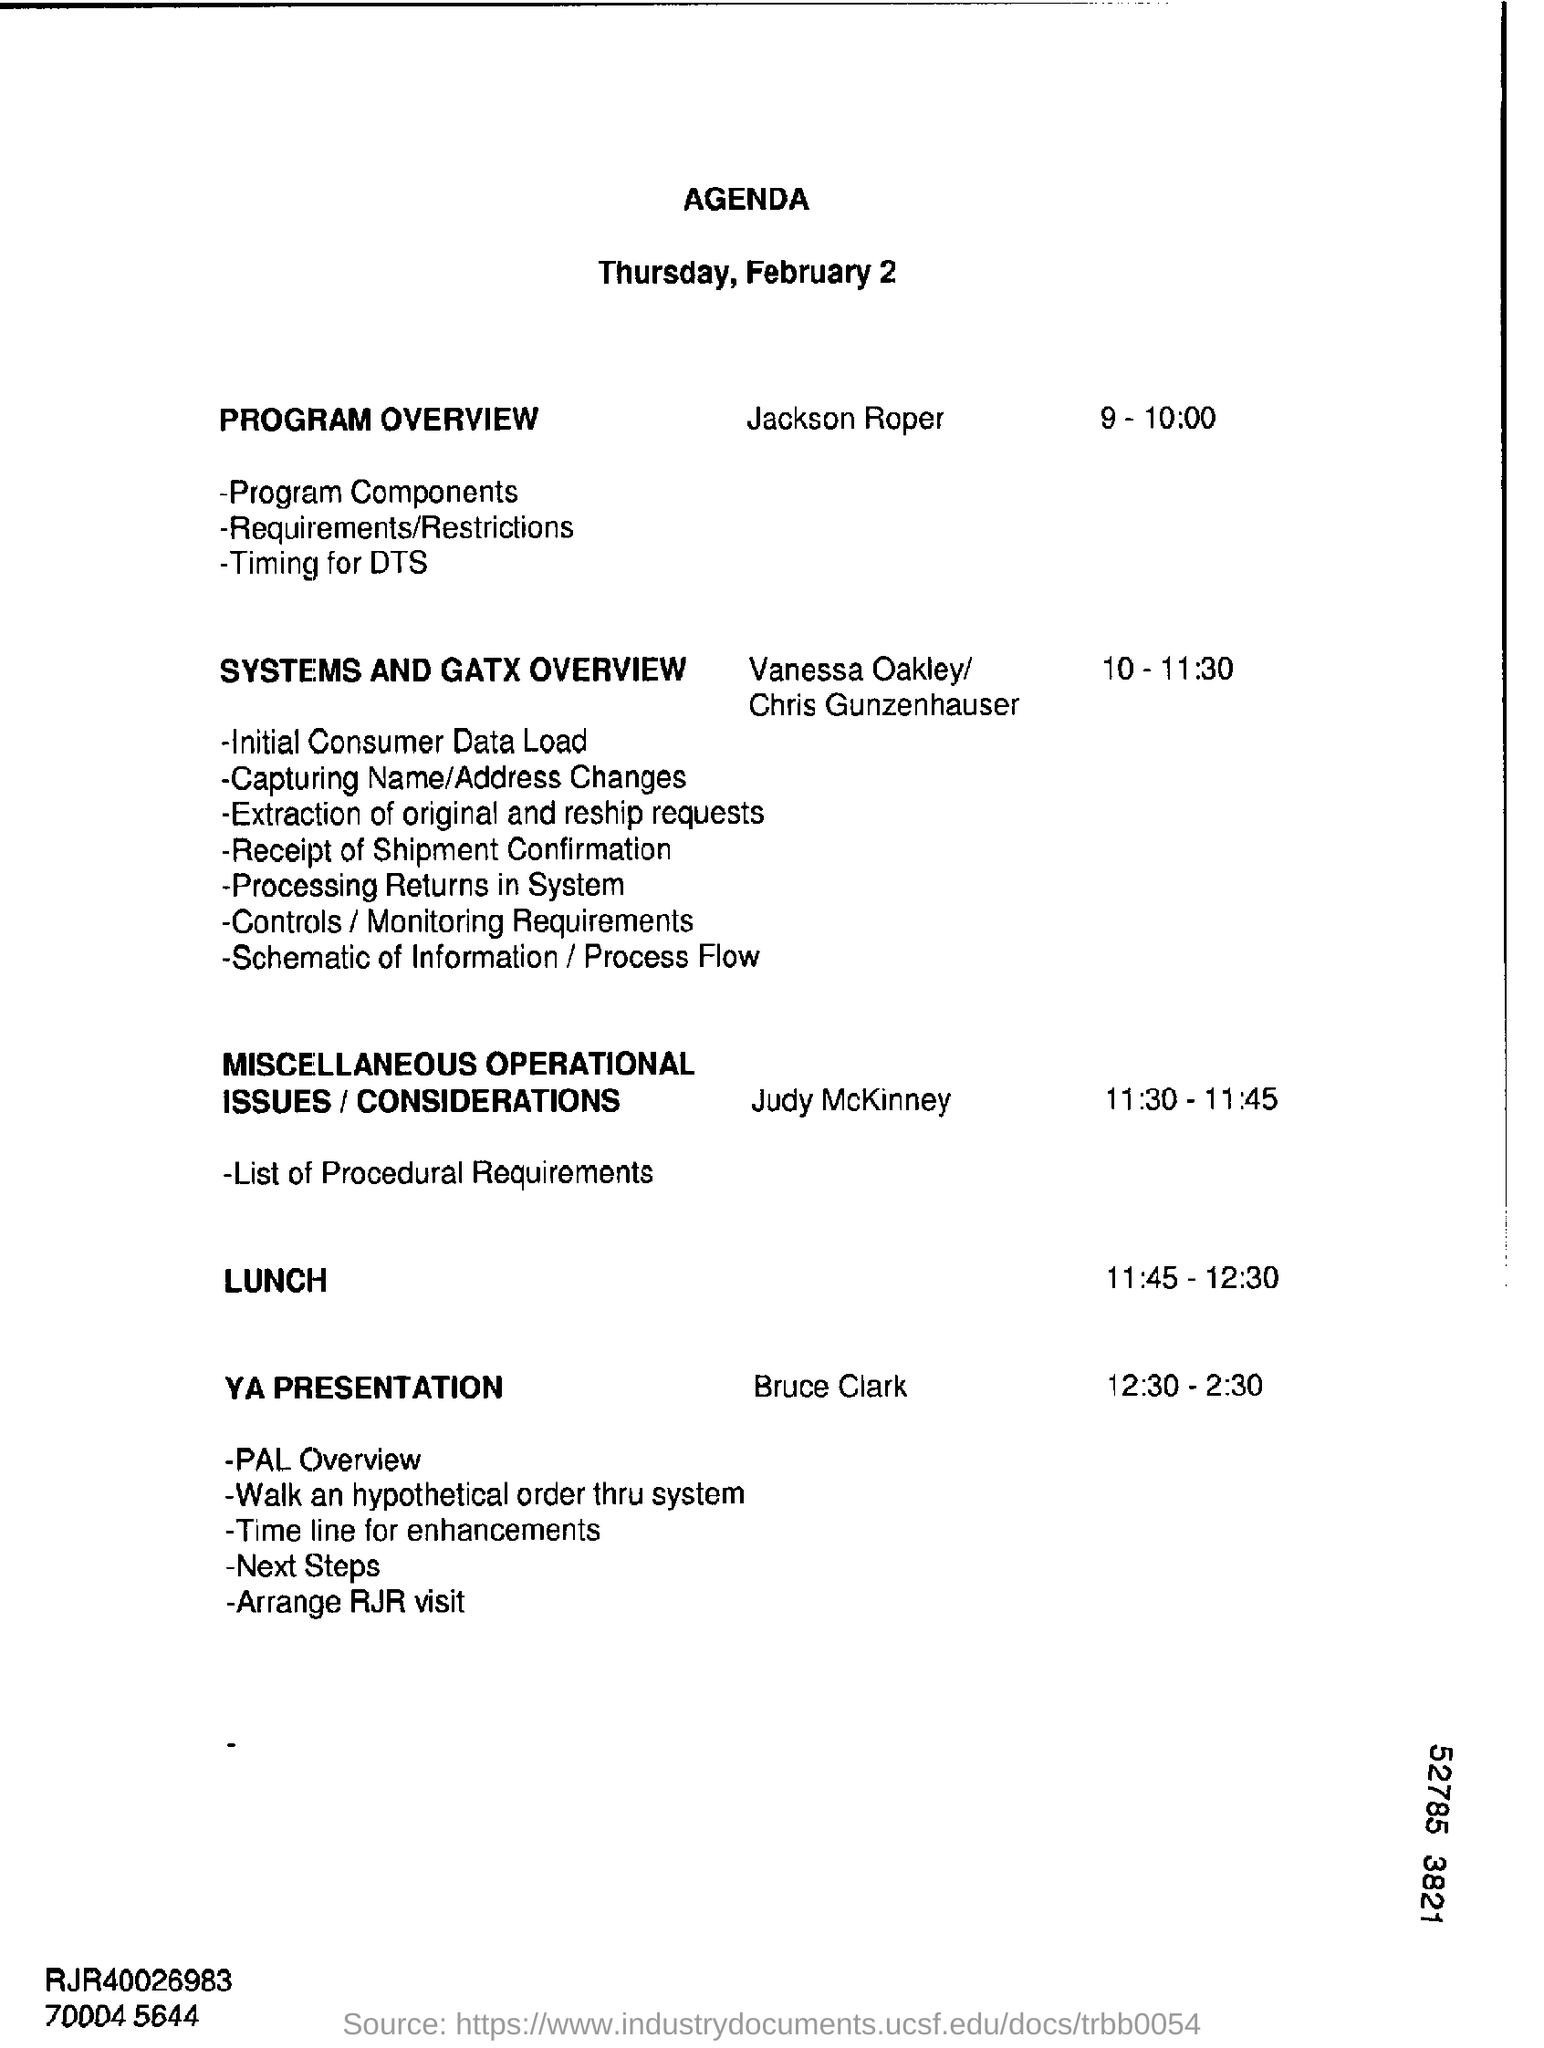Indicate a few pertinent items in this graphic. The PROGRAM OVERVIEW is scheduled to take place from 9:00-10:00 on [DATE]. The timing for the YA presentation by Bruce Clark is from 12:30 to 2:30. 